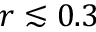Convert formula to latex. <formula><loc_0><loc_0><loc_500><loc_500>r \lesssim 0 . 3</formula> 